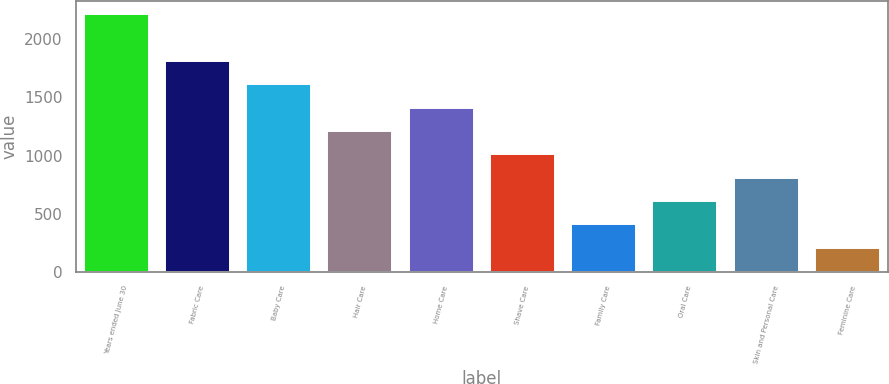Convert chart to OTSL. <chart><loc_0><loc_0><loc_500><loc_500><bar_chart><fcel>Years ended June 30<fcel>Fabric Care<fcel>Baby Care<fcel>Hair Care<fcel>Home Care<fcel>Shave Care<fcel>Family Care<fcel>Oral Care<fcel>Skin and Personal Care<fcel>Feminine Care<nl><fcel>2217.1<fcel>1814.9<fcel>1613.8<fcel>1211.6<fcel>1412.7<fcel>1010.5<fcel>407.2<fcel>608.3<fcel>809.4<fcel>206.1<nl></chart> 